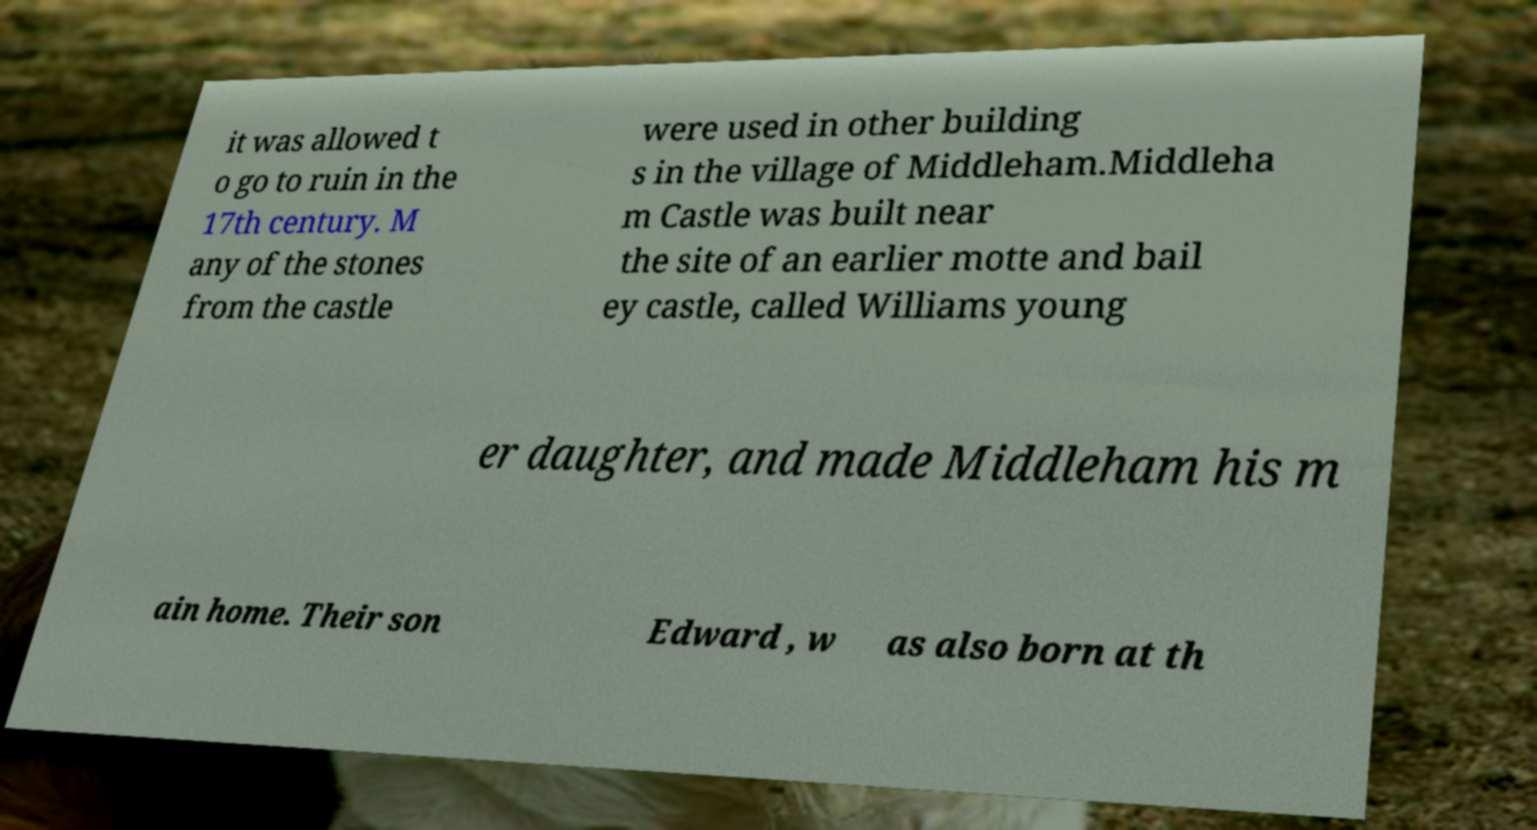Please read and relay the text visible in this image. What does it say? it was allowed t o go to ruin in the 17th century. M any of the stones from the castle were used in other building s in the village of Middleham.Middleha m Castle was built near the site of an earlier motte and bail ey castle, called Williams young er daughter, and made Middleham his m ain home. Their son Edward , w as also born at th 